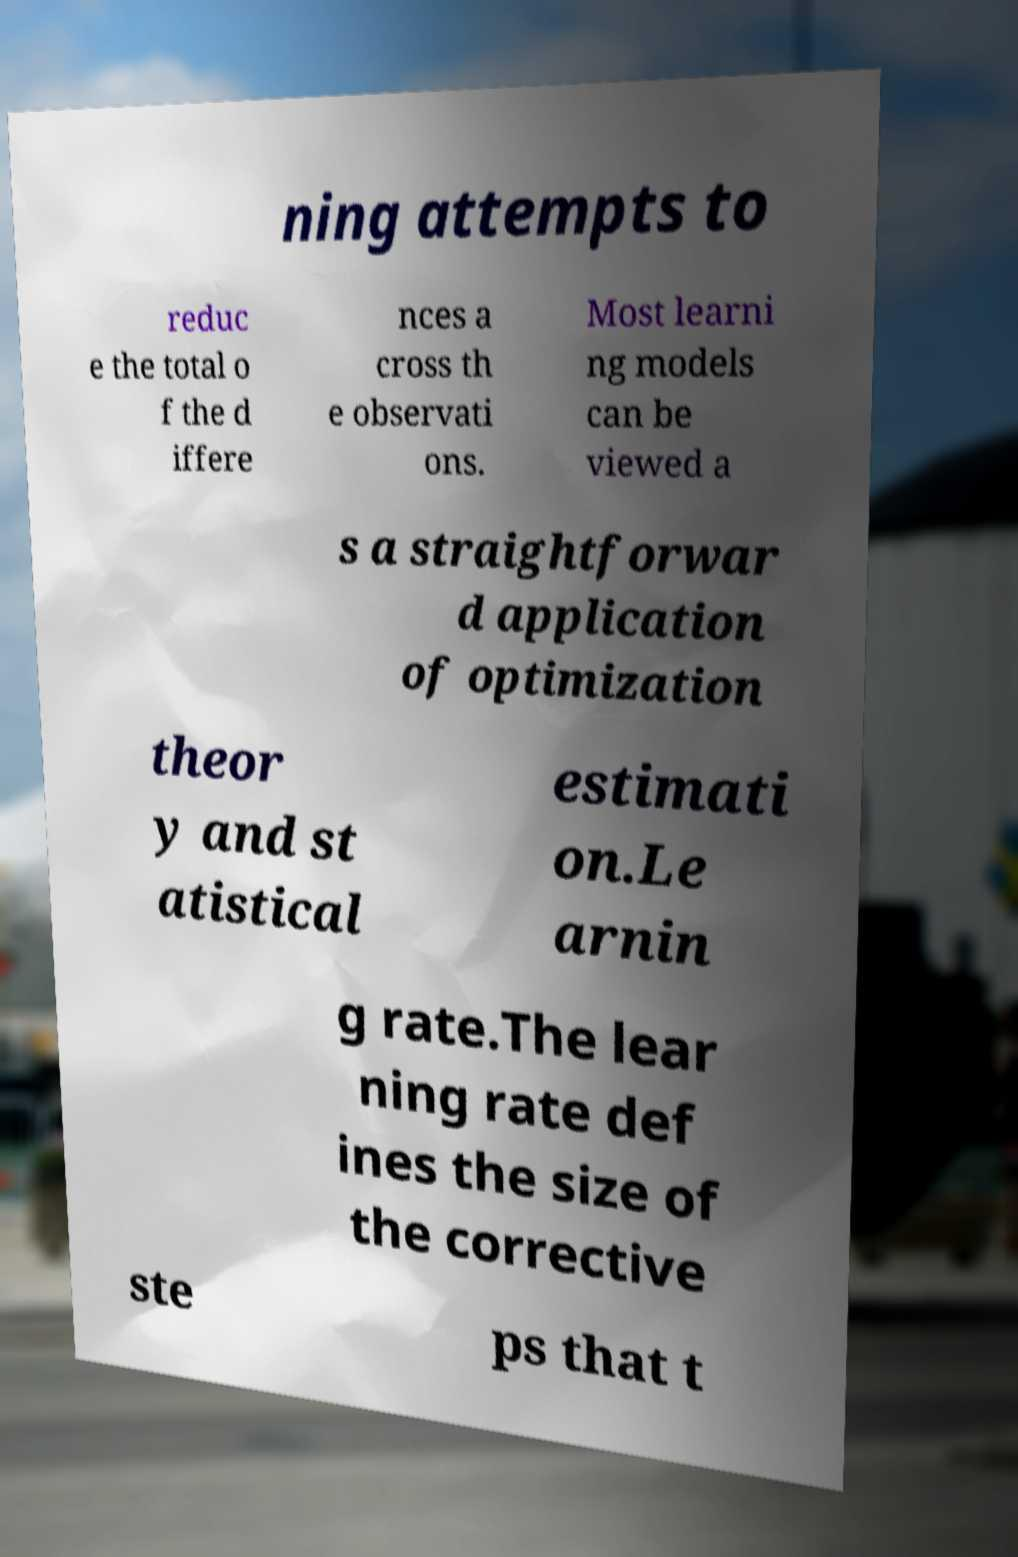I need the written content from this picture converted into text. Can you do that? ning attempts to reduc e the total o f the d iffere nces a cross th e observati ons. Most learni ng models can be viewed a s a straightforwar d application of optimization theor y and st atistical estimati on.Le arnin g rate.The lear ning rate def ines the size of the corrective ste ps that t 